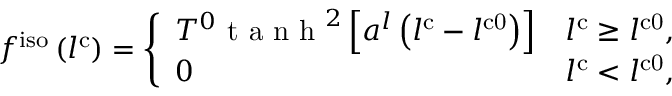<formula> <loc_0><loc_0><loc_500><loc_500>f ^ { i s o } \left ( l ^ { c } \right ) = \left \{ \begin{array} { l l } { T ^ { 0 } t a n h ^ { 2 } \left [ a ^ { l } \left ( l ^ { c } - l ^ { c 0 } \right ) \right ] } & { l ^ { c } \geq l ^ { c 0 } , } \\ { 0 } & { l ^ { c } < l ^ { c 0 } , } \end{array}</formula> 